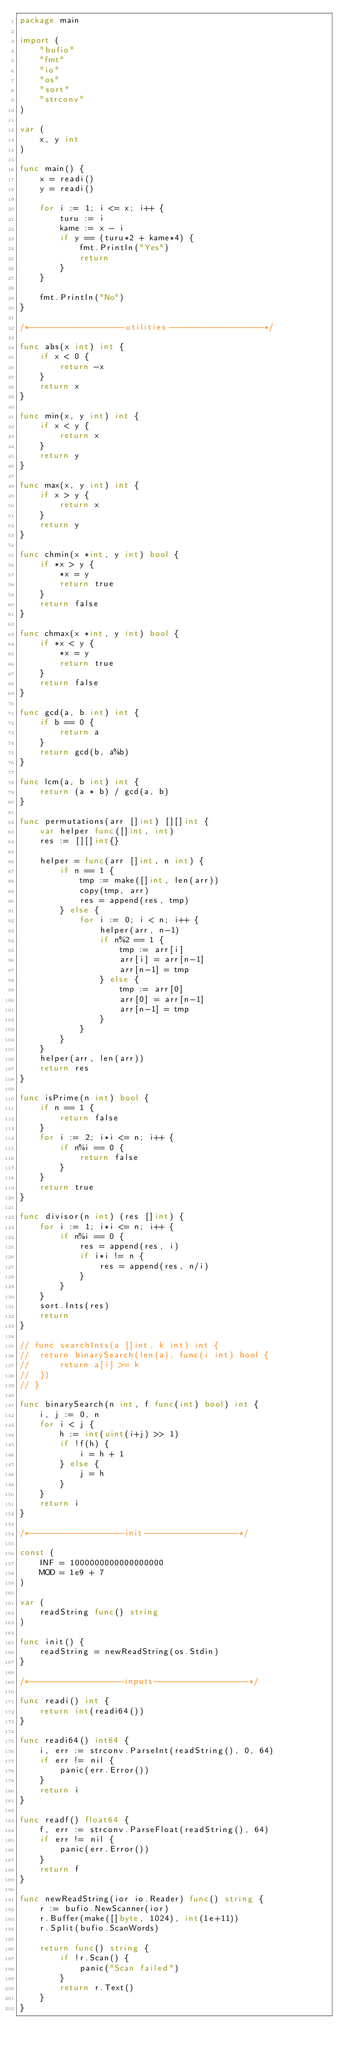Convert code to text. <code><loc_0><loc_0><loc_500><loc_500><_Go_>package main

import (
	"bufio"
	"fmt"
	"io"
	"os"
	"sort"
	"strconv"
)

var (
	x, y int
)

func main() {
	x = readi()
	y = readi()

	for i := 1; i <= x; i++ {
		turu := i
		kame := x - i
		if y == (turu*2 + kame*4) {
			fmt.Println("Yes")
			return
		}
	}

	fmt.Println("No")
}

/*-------------------utilities-------------------*/

func abs(x int) int {
	if x < 0 {
		return -x
	}
	return x
}

func min(x, y int) int {
	if x < y {
		return x
	}
	return y
}

func max(x, y int) int {
	if x > y {
		return x
	}
	return y
}

func chmin(x *int, y int) bool {
	if *x > y {
		*x = y
		return true
	}
	return false
}

func chmax(x *int, y int) bool {
	if *x < y {
		*x = y
		return true
	}
	return false
}

func gcd(a, b int) int {
	if b == 0 {
		return a
	}
	return gcd(b, a%b)
}

func lcm(a, b int) int {
	return (a * b) / gcd(a, b)
}

func permutations(arr []int) [][]int {
	var helper func([]int, int)
	res := [][]int{}

	helper = func(arr []int, n int) {
		if n == 1 {
			tmp := make([]int, len(arr))
			copy(tmp, arr)
			res = append(res, tmp)
		} else {
			for i := 0; i < n; i++ {
				helper(arr, n-1)
				if n%2 == 1 {
					tmp := arr[i]
					arr[i] = arr[n-1]
					arr[n-1] = tmp
				} else {
					tmp := arr[0]
					arr[0] = arr[n-1]
					arr[n-1] = tmp
				}
			}
		}
	}
	helper(arr, len(arr))
	return res
}

func isPrime(n int) bool {
	if n == 1 {
		return false
	}
	for i := 2; i*i <= n; i++ {
		if n%i == 0 {
			return false
		}
	}
	return true
}

func divisor(n int) (res []int) {
	for i := 1; i*i <= n; i++ {
		if n%i == 0 {
			res = append(res, i)
			if i*i != n {
				res = append(res, n/i)
			}
		}
	}
	sort.Ints(res)
	return
}

// func searchInts(a []int, k int) int {
// 	return binarySearch(len(a), func(i int) bool {
// 		return a[i] >= k
// 	})
// }

func binarySearch(n int, f func(int) bool) int {
	i, j := 0, n
	for i < j {
		h := int(uint(i+j) >> 1)
		if !f(h) {
			i = h + 1
		} else {
			j = h
		}
	}
	return i
}

/*-------------------init-------------------*/

const (
	INF = 1000000000000000000
	MOD = 1e9 + 7
)

var (
	readString func() string
)

func init() {
	readString = newReadString(os.Stdin)
}

/*-------------------inputs-------------------*/

func readi() int {
	return int(readi64())
}

func readi64() int64 {
	i, err := strconv.ParseInt(readString(), 0, 64)
	if err != nil {
		panic(err.Error())
	}
	return i
}

func readf() float64 {
	f, err := strconv.ParseFloat(readString(), 64)
	if err != nil {
		panic(err.Error())
	}
	return f
}

func newReadString(ior io.Reader) func() string {
	r := bufio.NewScanner(ior)
	r.Buffer(make([]byte, 1024), int(1e+11))
	r.Split(bufio.ScanWords)

	return func() string {
		if !r.Scan() {
			panic("Scan failed")
		}
		return r.Text()
	}
}
</code> 